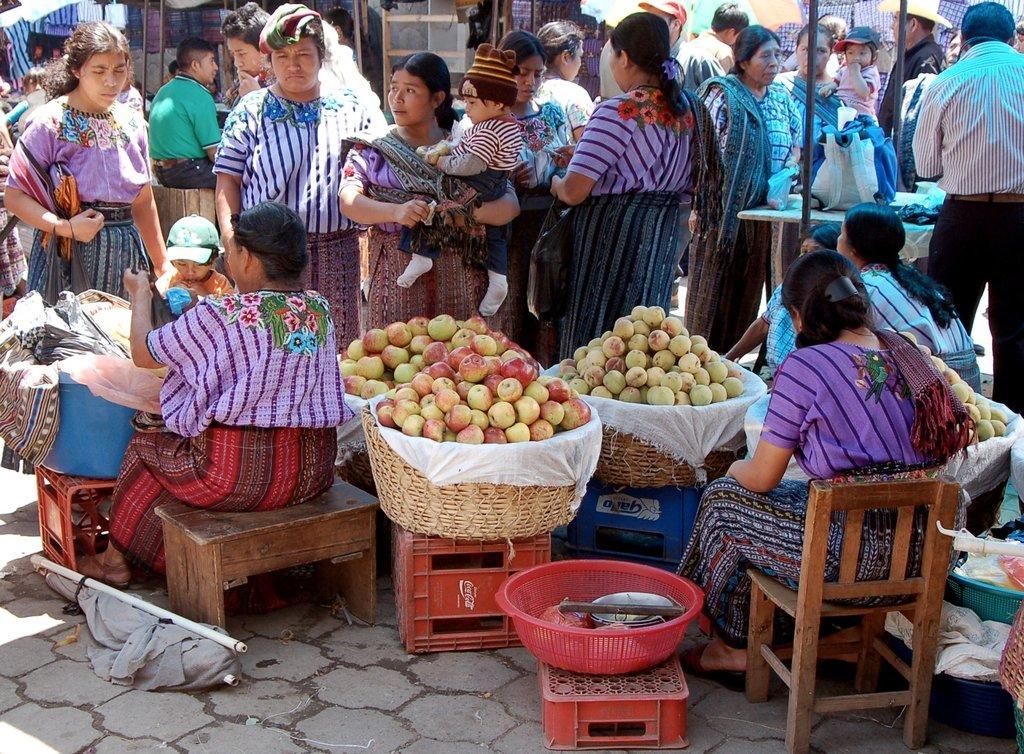Describe this image in one or two sentences. Here we can see some are sitting and some are standing on the floor, and here are the fruits on the basket. 